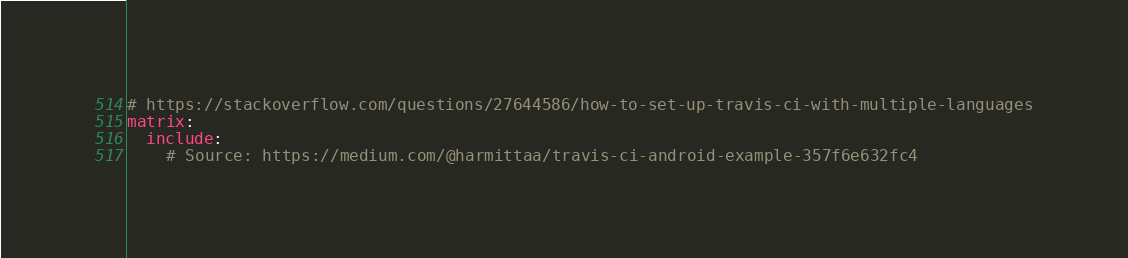<code> <loc_0><loc_0><loc_500><loc_500><_YAML_># https://stackoverflow.com/questions/27644586/how-to-set-up-travis-ci-with-multiple-languages
matrix:
  include:
    # Source: https://medium.com/@harmittaa/travis-ci-android-example-357f6e632fc4</code> 